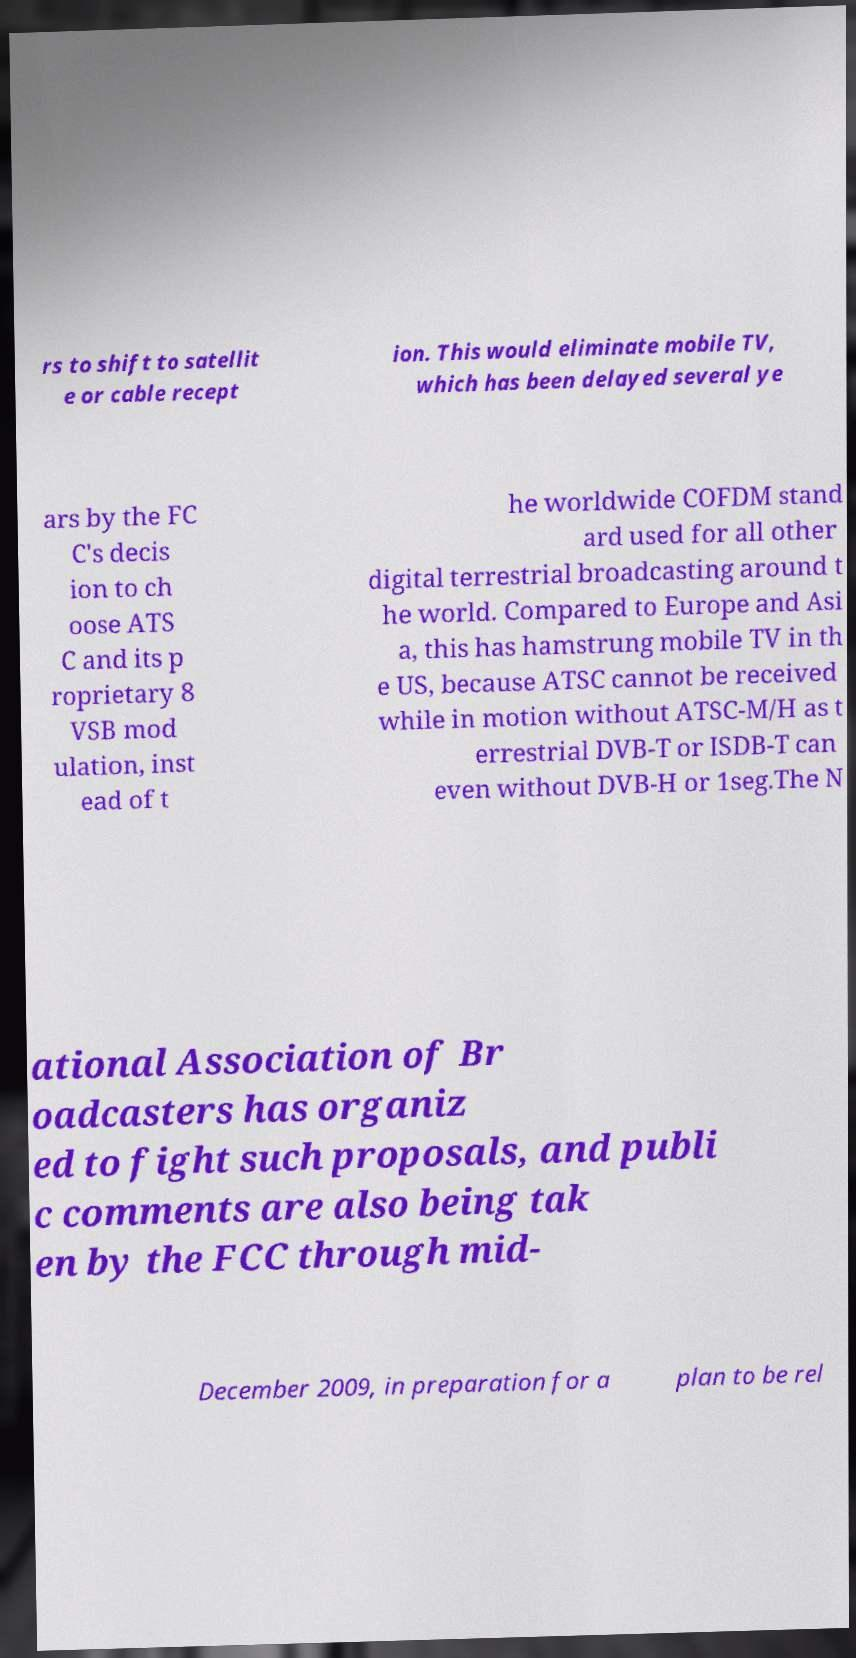Could you extract and type out the text from this image? rs to shift to satellit e or cable recept ion. This would eliminate mobile TV, which has been delayed several ye ars by the FC C's decis ion to ch oose ATS C and its p roprietary 8 VSB mod ulation, inst ead of t he worldwide COFDM stand ard used for all other digital terrestrial broadcasting around t he world. Compared to Europe and Asi a, this has hamstrung mobile TV in th e US, because ATSC cannot be received while in motion without ATSC-M/H as t errestrial DVB-T or ISDB-T can even without DVB-H or 1seg.The N ational Association of Br oadcasters has organiz ed to fight such proposals, and publi c comments are also being tak en by the FCC through mid- December 2009, in preparation for a plan to be rel 